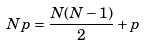<formula> <loc_0><loc_0><loc_500><loc_500>N p = \frac { N ( N - 1 ) } { 2 } + p</formula> 